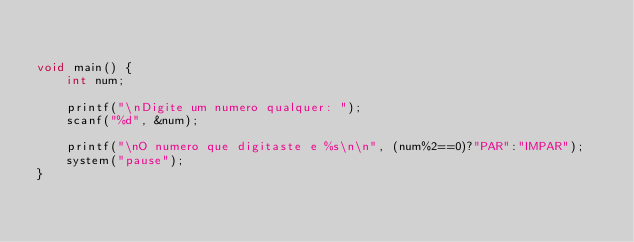<code> <loc_0><loc_0><loc_500><loc_500><_C_>

void main() {
    int num;

    printf("\nDigite um numero qualquer: ");
    scanf("%d", &num);

    printf("\nO numero que digitaste e %s\n\n", (num%2==0)?"PAR":"IMPAR");
    system("pause");
}</code> 